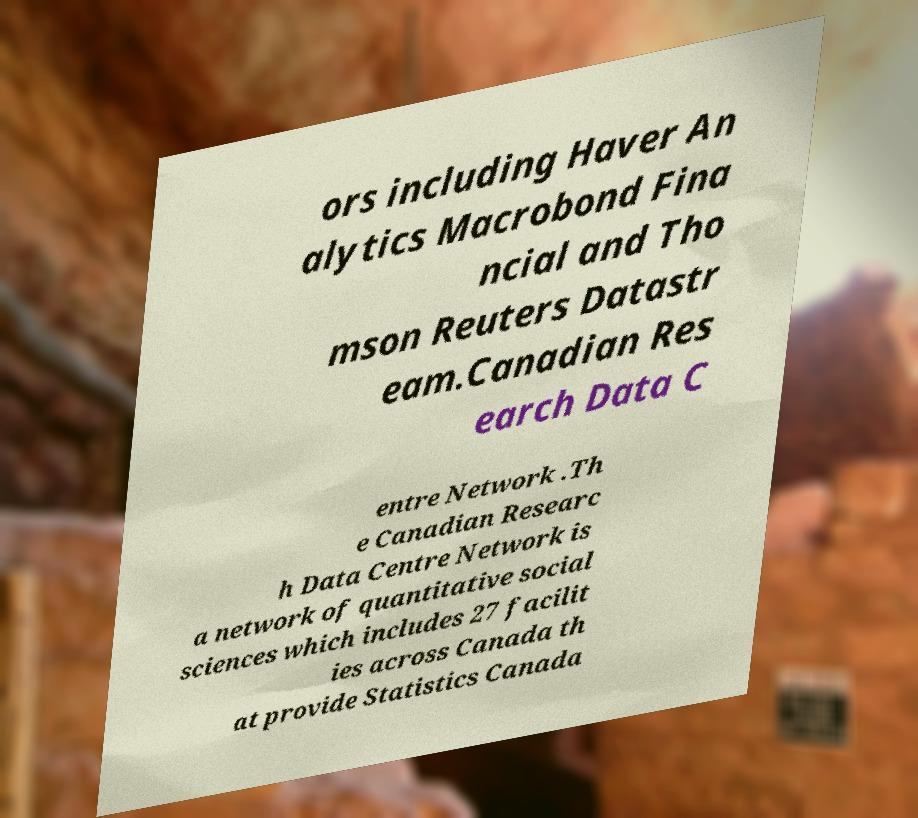Could you assist in decoding the text presented in this image and type it out clearly? ors including Haver An alytics Macrobond Fina ncial and Tho mson Reuters Datastr eam.Canadian Res earch Data C entre Network .Th e Canadian Researc h Data Centre Network is a network of quantitative social sciences which includes 27 facilit ies across Canada th at provide Statistics Canada 